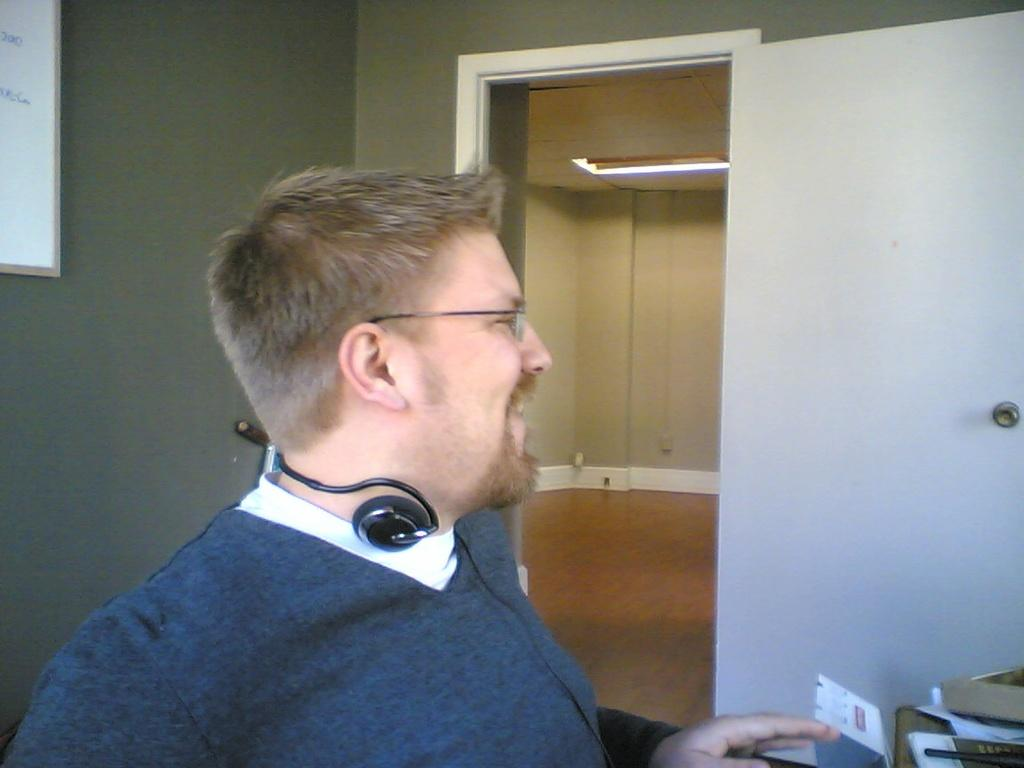Who is present in the image? There is a man in the image. What is the man wearing around his neck? The man is wearing headphones around his neck. What can be seen in the background of the image? There is a whiteboard and walls visible in the background of the image. Are there any objects related to learning or reading in the image? Yes, there is a book in the background of the image. What type of suit is the man wearing in the image? The man is not wearing a suit in the image; he is wearing headphones around his neck. 